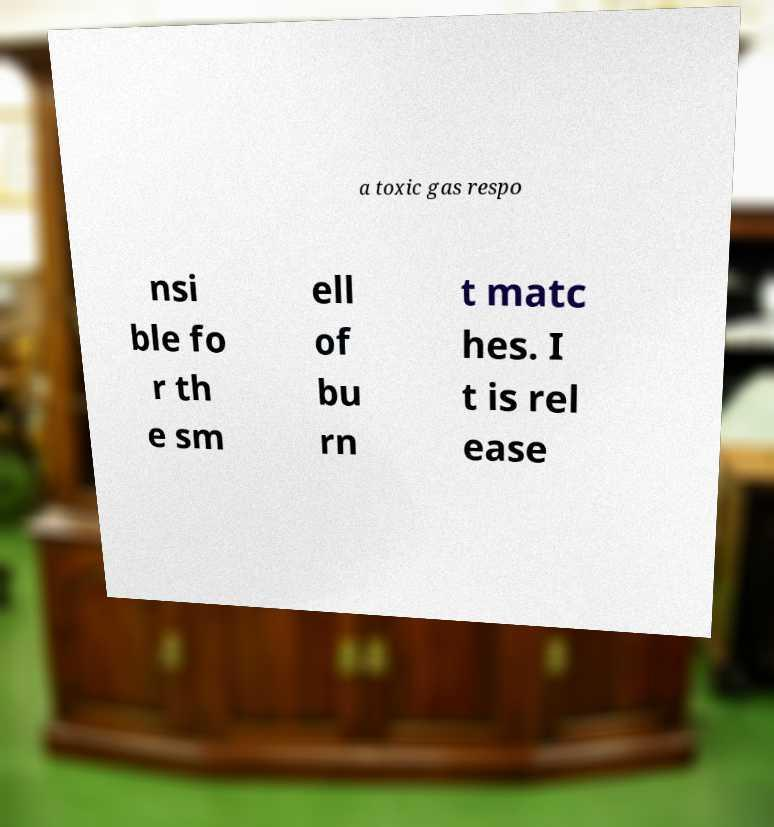Please identify and transcribe the text found in this image. a toxic gas respo nsi ble fo r th e sm ell of bu rn t matc hes. I t is rel ease 